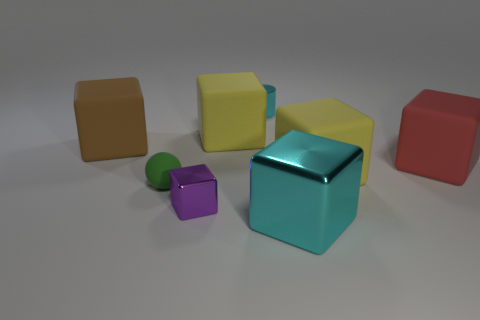There is a small metallic object that is in front of the small cylinder; is its color the same as the tiny matte ball?
Your answer should be compact. No. What material is the yellow cube that is in front of the red thing?
Provide a succinct answer. Rubber. Is the number of red blocks that are on the left side of the tiny cube the same as the number of large rubber cubes?
Provide a succinct answer. No. What number of large metallic cubes have the same color as the tiny block?
Offer a very short reply. 0. The other metal thing that is the same shape as the big metallic object is what color?
Provide a short and direct response. Purple. Do the metallic cylinder and the purple thing have the same size?
Your response must be concise. Yes. Are there the same number of tiny purple shiny blocks that are in front of the big cyan shiny block and large yellow matte cubes that are left of the tiny block?
Your answer should be compact. Yes. Are any tiny metal blocks visible?
Your answer should be very brief. Yes. There is a cyan shiny object that is the same shape as the large red matte object; what size is it?
Provide a succinct answer. Large. There is a cyan object behind the tiny matte sphere; how big is it?
Your response must be concise. Small. 